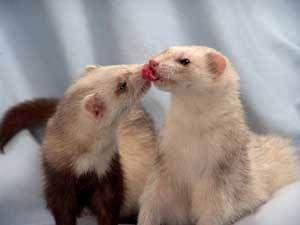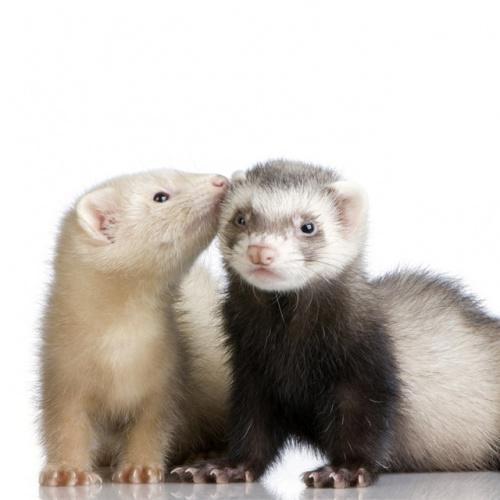The first image is the image on the left, the second image is the image on the right. Assess this claim about the two images: "There is both a white in a brown ferret in the picture however only the brown tail is visible.". Correct or not? Answer yes or no. Yes. 